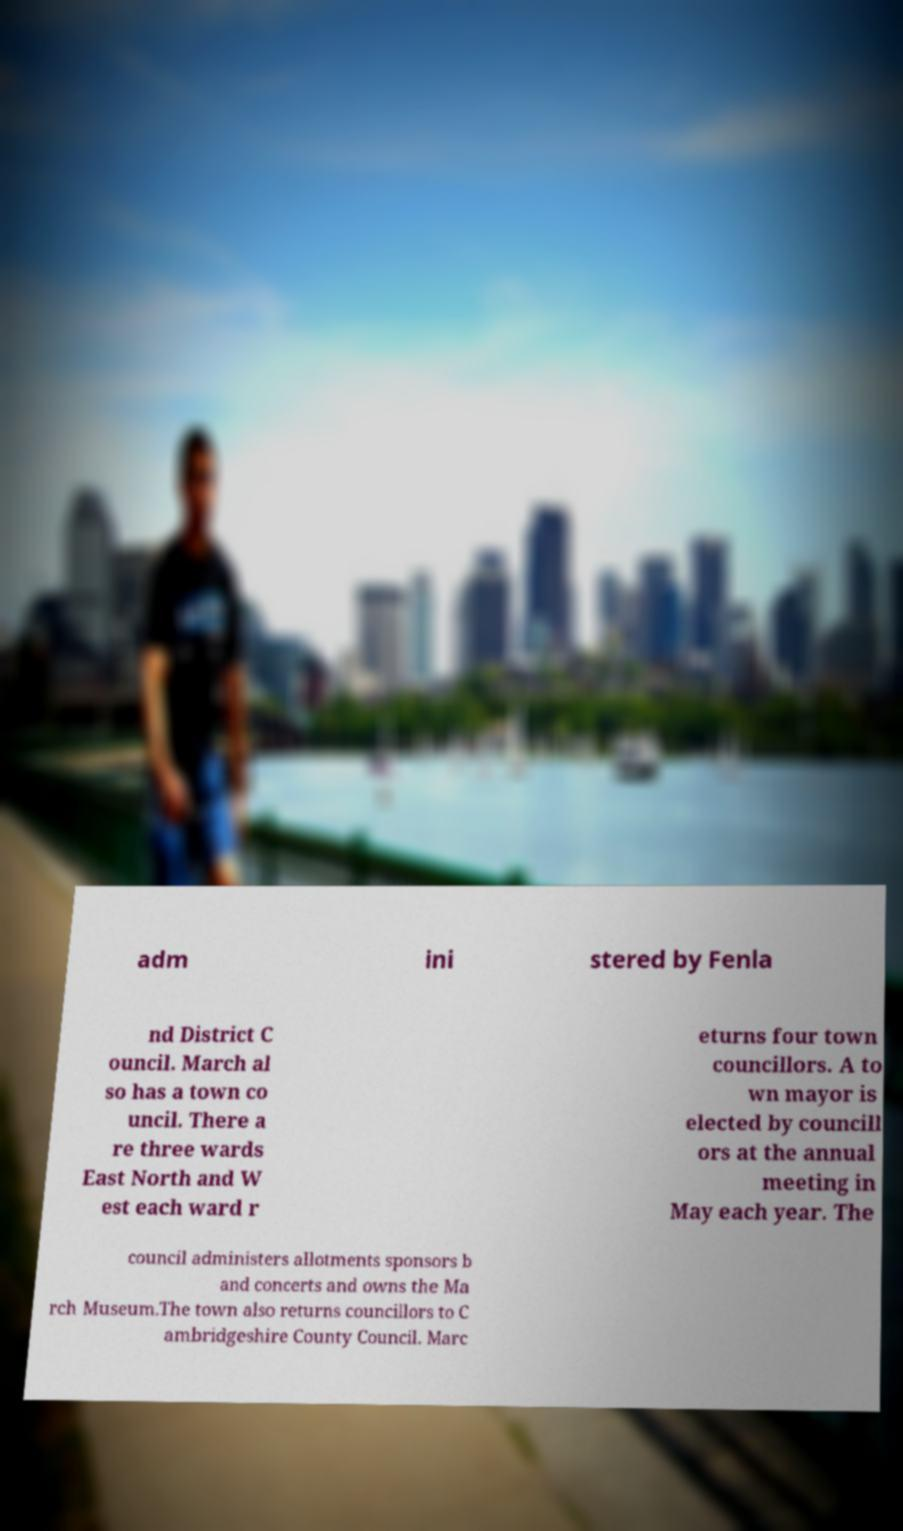Can you read and provide the text displayed in the image?This photo seems to have some interesting text. Can you extract and type it out for me? adm ini stered by Fenla nd District C ouncil. March al so has a town co uncil. There a re three wards East North and W est each ward r eturns four town councillors. A to wn mayor is elected by councill ors at the annual meeting in May each year. The council administers allotments sponsors b and concerts and owns the Ma rch Museum.The town also returns councillors to C ambridgeshire County Council. Marc 